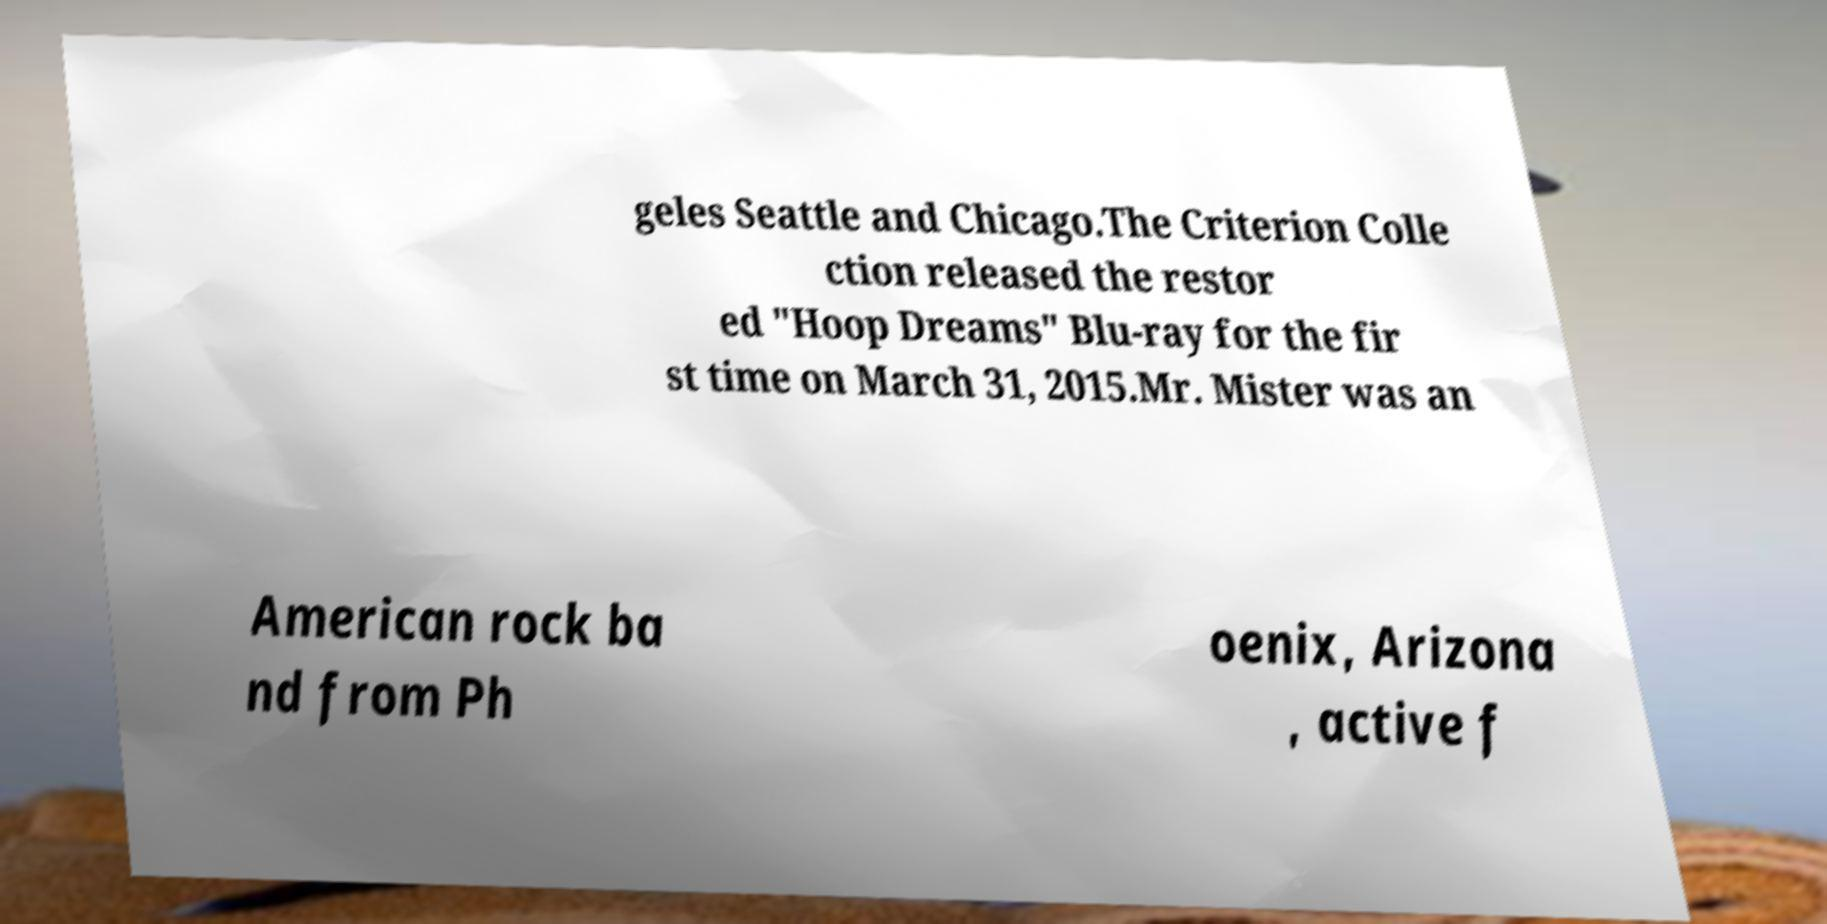I need the written content from this picture converted into text. Can you do that? geles Seattle and Chicago.The Criterion Colle ction released the restor ed "Hoop Dreams" Blu-ray for the fir st time on March 31, 2015.Mr. Mister was an American rock ba nd from Ph oenix, Arizona , active f 